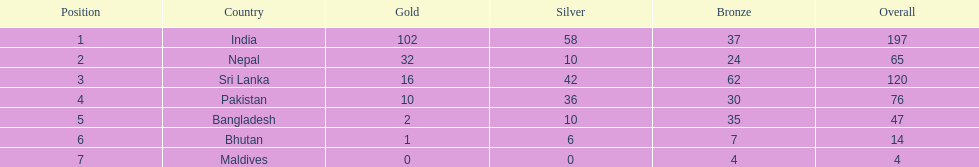Who has won the most bronze medals? Sri Lanka. 